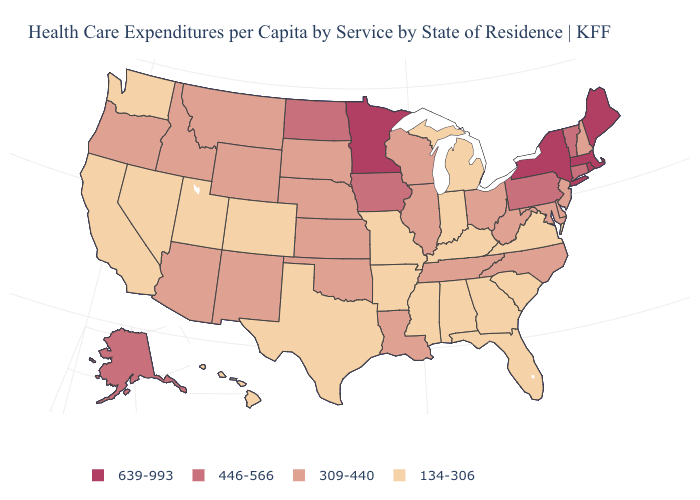How many symbols are there in the legend?
Concise answer only. 4. What is the value of Alabama?
Be succinct. 134-306. What is the value of Indiana?
Answer briefly. 134-306. Name the states that have a value in the range 309-440?
Answer briefly. Arizona, Delaware, Idaho, Illinois, Kansas, Louisiana, Maryland, Montana, Nebraska, New Hampshire, New Jersey, New Mexico, North Carolina, Ohio, Oklahoma, Oregon, South Dakota, Tennessee, West Virginia, Wisconsin, Wyoming. Name the states that have a value in the range 639-993?
Concise answer only. Maine, Massachusetts, Minnesota, New York, Rhode Island. Which states have the lowest value in the MidWest?
Write a very short answer. Indiana, Michigan, Missouri. Does Hawaii have a lower value than Utah?
Concise answer only. No. How many symbols are there in the legend?
Quick response, please. 4. Does Delaware have the highest value in the South?
Answer briefly. Yes. What is the value of Pennsylvania?
Be succinct. 446-566. Which states have the lowest value in the USA?
Write a very short answer. Alabama, Arkansas, California, Colorado, Florida, Georgia, Hawaii, Indiana, Kentucky, Michigan, Mississippi, Missouri, Nevada, South Carolina, Texas, Utah, Virginia, Washington. How many symbols are there in the legend?
Keep it brief. 4. What is the value of Virginia?
Write a very short answer. 134-306. What is the value of Delaware?
Quick response, please. 309-440. 